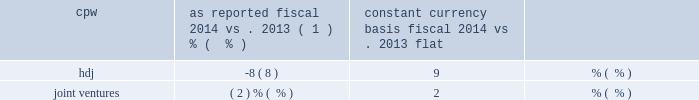22 general mills 2014 annual report 23 gross margin declined 1 percent in fiscal 2014 versus fiscal 2013 .
Gross margin as a percent of net sales of 36 percent was relatively flat compared to fiscal 2013 .
Selling , general and administrative ( sg&a ) expenses decreased $ 78 million in fiscal 2014 versus fiscal 2013 .
The decrease in sg&a expenses was primarily driven by a 3 percent decrease in advertising and media expense , a smaller contribution to the general mills foundation , a decrease in incentive compensation expense and lower pension expense compared to fiscal 2013 .
In fiscal 2014 , we recorded a $ 39 million charge related to venezuela currency devaluation compared to a $ 9 million charge in fiscal 2013 .
In addition , we recorded $ 12 million of inte- gration costs in fiscal 2013 related to our acquisition of yoki .
Sg&a expenses as a percent of net sales decreased 1 percent compared to fiscal 2013 .
Restructuring , impairment , and other exit costs totaled $ 4 million in fiscal 2014 .
The restructuring charge related to a productivity and cost savings plan approved in the fourth quarter of fiscal 2012 .
These restructuring actions were completed in fiscal 2014 .
In fiscal 2014 , we paid $ 22 million in cash related to restructuring actions .
During fiscal 2014 , we recorded a divestiture gain of $ 66 million related to the sale of certain grain elevators in our u.s .
Retail segment .
There were no divestitures in fiscal 2013 .
Interest , net for fiscal 2014 totaled $ 302 million , $ 15 million lower than fiscal 2013 .
The average interest rate decreased 41 basis points , including the effect of the mix of debt , generating a $ 31 million decrease in net interest .
Average interest bearing instruments increased $ 367 million , generating a $ 16 million increase in net interest .
Our consolidated effective tax rate for fiscal 2014 was 33.3 percent compared to 29.2 percent in fiscal 2013 .
The 4.1 percentage point increase was primarily related to the restructuring of our general mills cereals , llc ( gmc ) subsidiary during the first quarter of 2013 which resulted in a $ 63 million decrease to deferred income tax liabilities related to the tax basis of the investment in gmc and certain distributed assets , with a correspond- ing non-cash reduction to income taxes .
During fiscal 2013 , we also recorded a $ 34 million discrete decrease in income tax expense and an increase in our deferred tax assets related to certain actions taken to restore part of the tax benefits associated with medicare part d subsidies which had previously been reduced in fiscal 2010 with the enactment of the patient protection and affordable care act , as amended by the health care and education reconciliation act of 2010 .
Our fiscal 2013 tax expense also includes a $ 12 million charge associated with the liquidation of a corporate investment .
After-tax earnings from joint ventures for fiscal 2014 decreased to $ 90 million compared to $ 99 million in fiscal 2013 primarily driven by increased consumer spending at cereal partners worldwide ( cpw ) and unfavorable foreign currency exchange from h e4agen- dazs japan , inc .
( hdj ) .
The change in net sales for each joint venture is set forth in the table : joint venture change in net sales as reported constant currency basis fiscal 2014 fiscal 2014 vs .
2013 vs .
2013 cpw ( 1 ) % (  % ) flat .
In fiscal 2014 , cpw net sales declined by 1 percent- age point due to unfavorable foreign currency exchange .
Contribution from volume growth was flat compared to fiscal 2013 .
In fiscal 2014 , net sales for hdj decreased 8 percentage points from fiscal 2013 as 11 percentage points of contributions from volume growth was offset by 17 percentage points of net sales decline from unfa- vorable foreign currency exchange and 2 percentage points of net sales decline attributable to unfavorable net price realization and mix .
Average diluted shares outstanding decreased by 20 million in fiscal 2014 from fiscal 2013 due primar- ily to the repurchase of 36 million shares , partially offset by the issuance of 7 million shares related to stock compensation plans .
Fiscal 2014 consolidated balance sheet analysis cash and cash equivalents increased $ 126 million from fiscal 2013 .
Receivables increased $ 37 million from fiscal 2013 pri- marily driven by timing of sales .
Inventories increased $ 14 million from fiscal 2013 .
Prepaid expenses and other current assets decreased $ 29 million from fiscal 2013 , mainly due to a decrease in other receivables related to the liquidation of a corporate investment .
Land , buildings , and equipment increased $ 64 million from fiscal 2013 , as $ 664 million of capital expenditures .
What is the growth rate of earnings generated from joint ventures from 2013 to 2014? 
Computations: ((90 - 99) / 99)
Answer: -0.09091. 